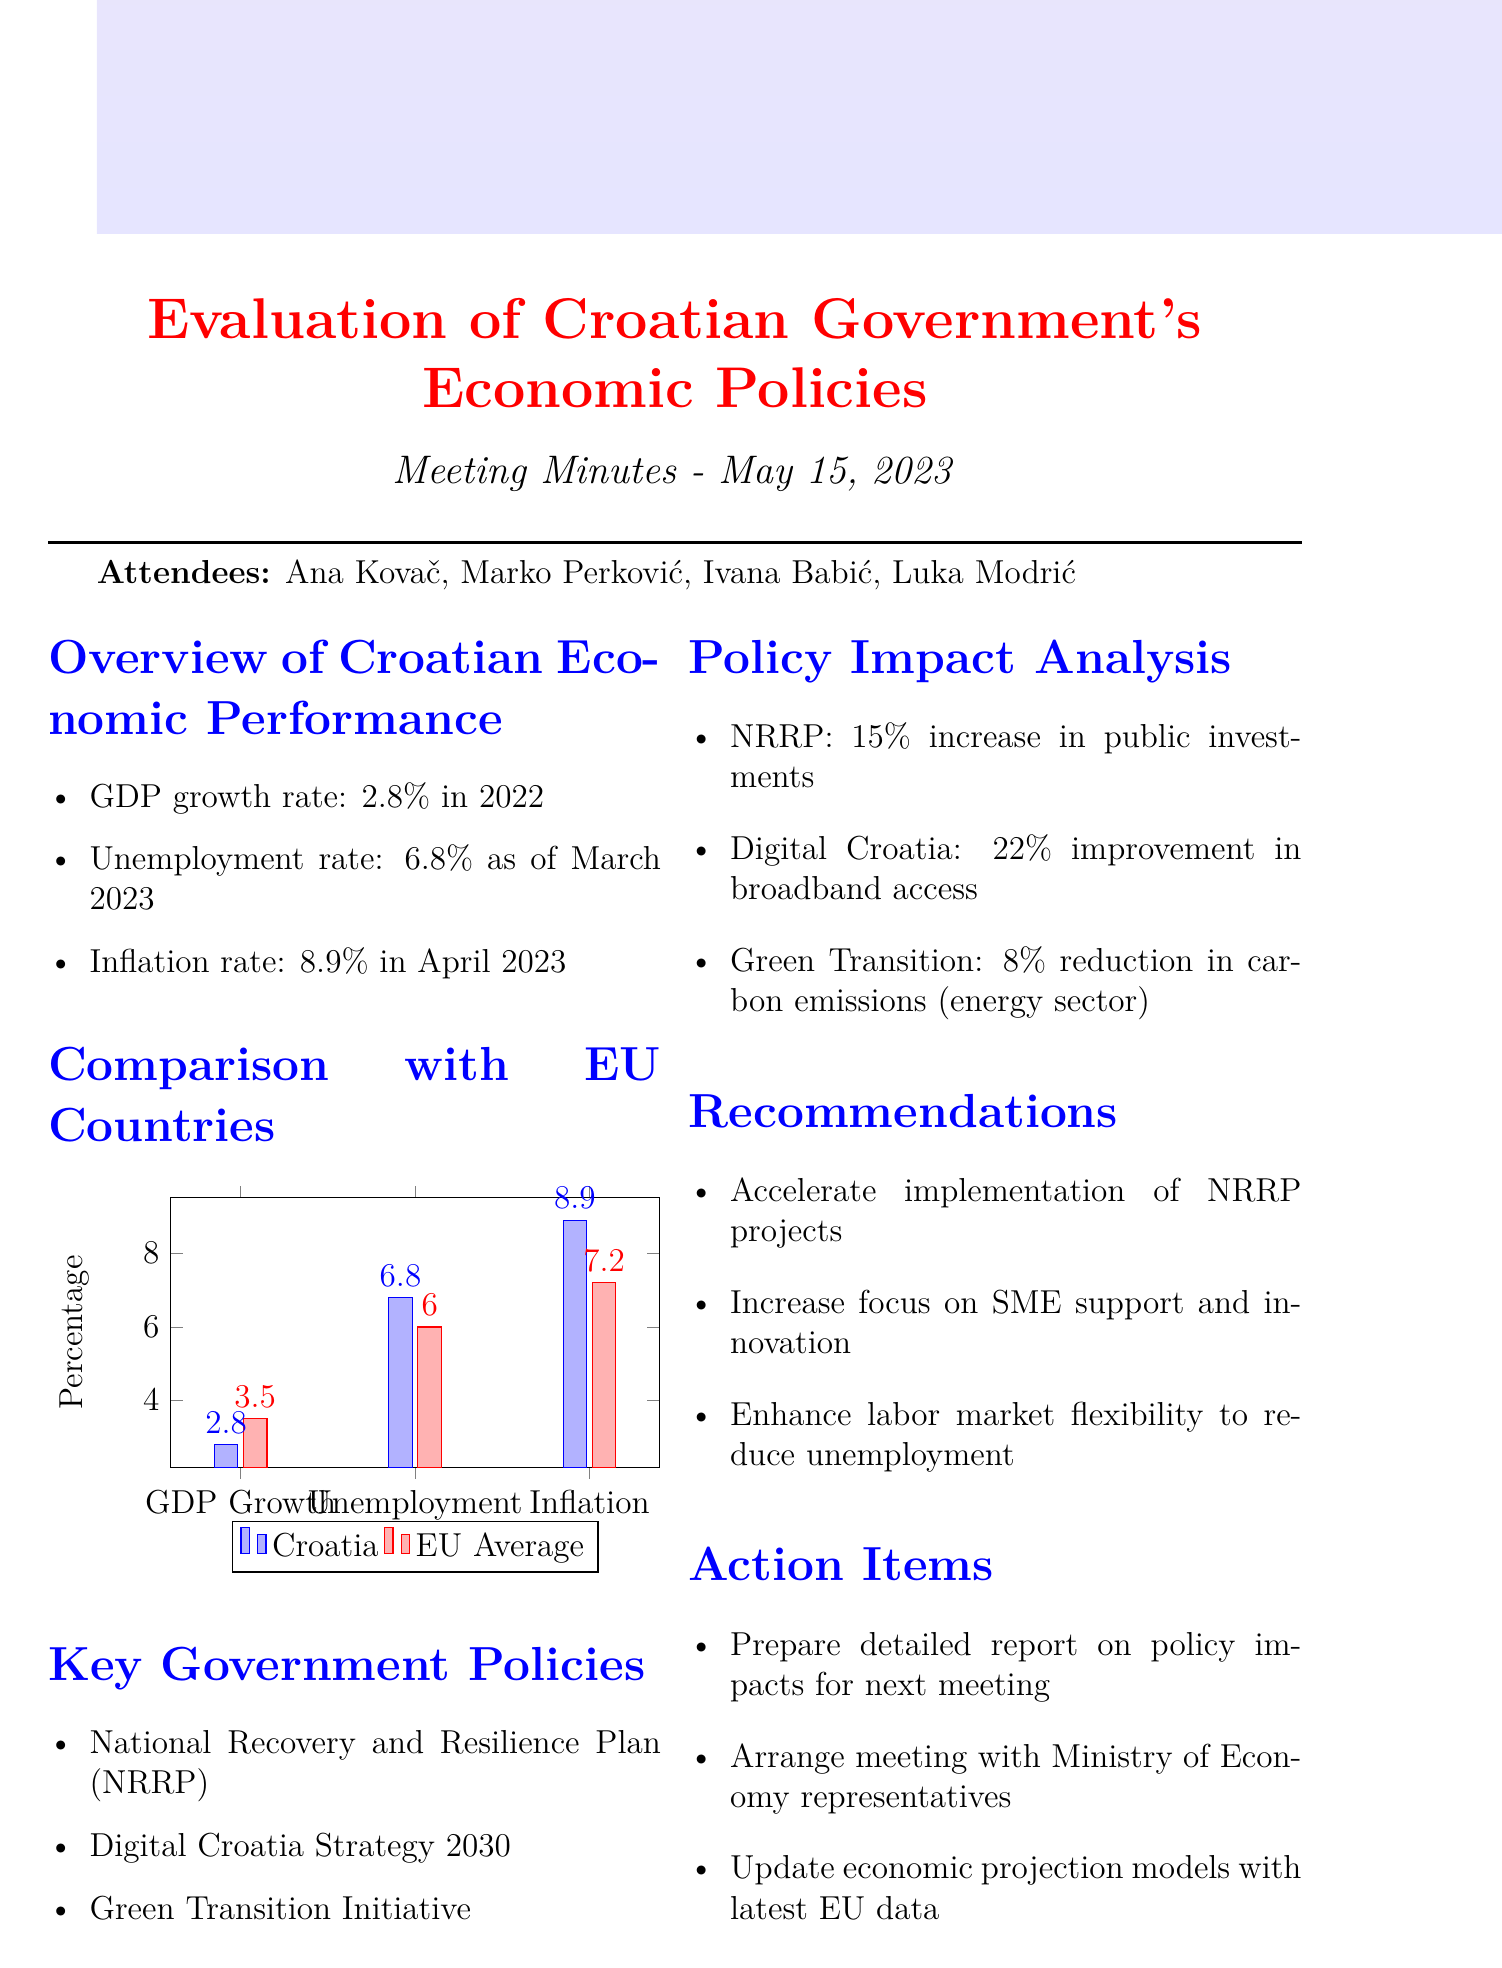What is the GDP growth rate for Croatia in 2022? The GDP growth rate for Croatia in 2022 is listed in the document under economic performance.
Answer: 2.8% What is the unemployment rate for Croatia as of March 2023? The document specifies the unemployment rate for Croatia as of March 2023.
Answer: 6.8% What was the inflation rate in Croatia in April 2023? The inflation rate for Croatia in April 2023 is mentioned in the overview section of the document.
Answer: 8.9% How much did the NRRP increase public investments? The document indicates the impact of the NRRP on public investments, which is stated.
Answer: 15% What is the EU average unemployment rate in 2022? The document compares various economic indicators for Croatia with the EU average, specifically noting the EU average unemployment rate.
Answer: 6.0% What are the three key government policies mentioned? The document explicitly lists the key government policies on the agenda.
Answer: National Recovery and Resilience Plan (NRRP), Digital Croatia Strategy 2030, Green Transition Initiative What percentage improvement in broadband access is attributed to the Digital Croatia Strategy? The document details the impact of the Digital Croatia Strategy as a specific percentage increase.
Answer: 22% What recommendation is made concerning SME support? The document contains suggestions aimed at enhancing SME support as part of the recommendations section.
Answer: Increase focus on SME support and innovation What type of chart is used to present the comparison with EU countries? The document states the type of chart used for comparing economic indicators.
Answer: Bar Chart 